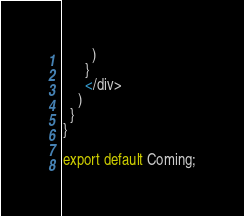<code> <loc_0><loc_0><loc_500><loc_500><_JavaScript_>        )
      }
      </div>
    )
  }
}

export default Coming;
</code> 